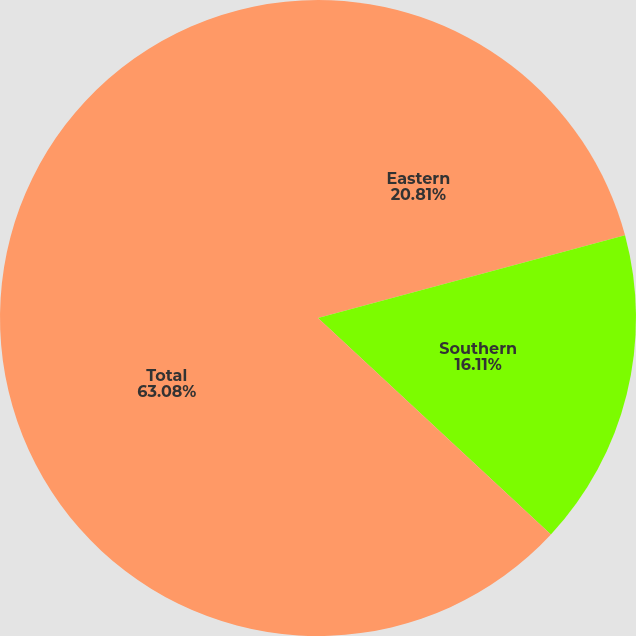<chart> <loc_0><loc_0><loc_500><loc_500><pie_chart><fcel>Eastern<fcel>Southern<fcel>Total<nl><fcel>20.81%<fcel>16.11%<fcel>63.08%<nl></chart> 